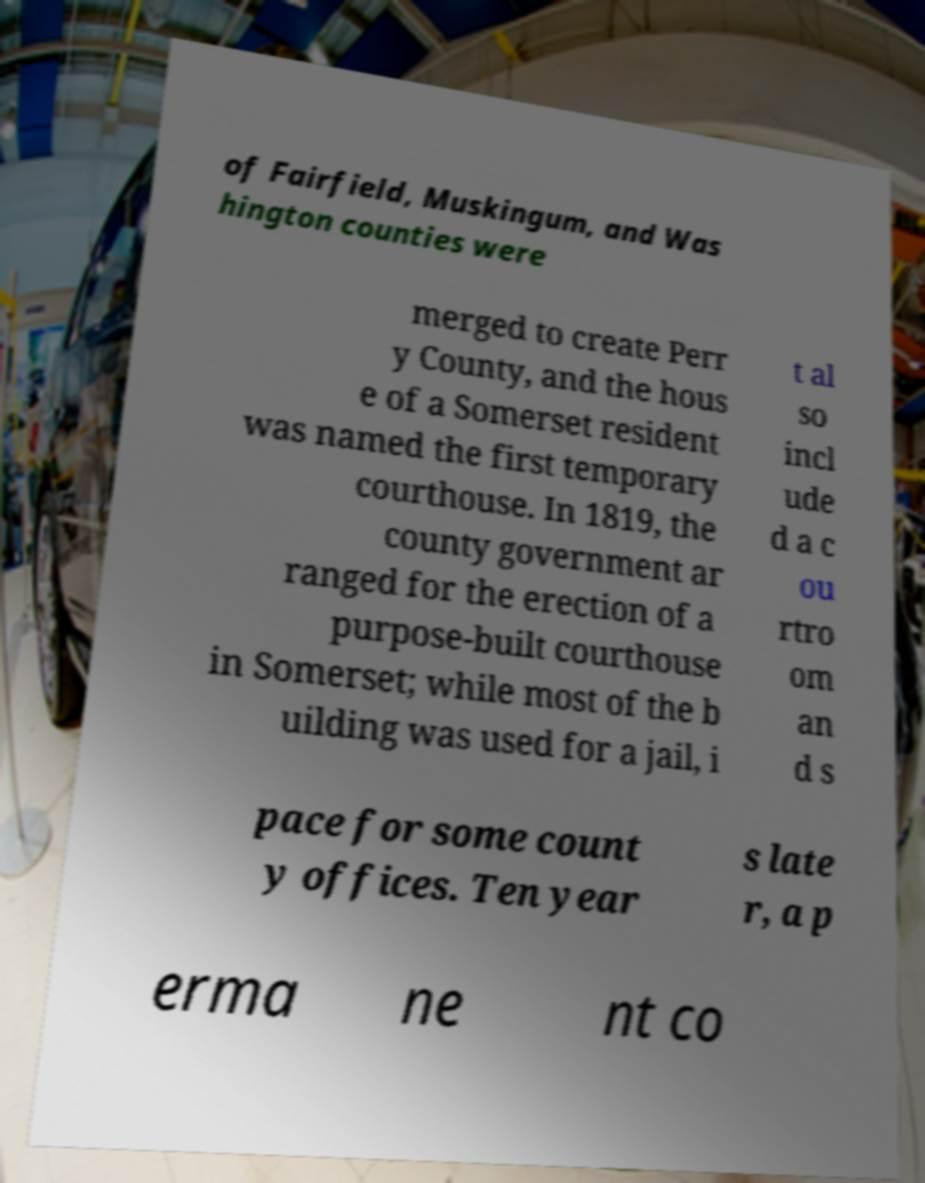Can you read and provide the text displayed in the image?This photo seems to have some interesting text. Can you extract and type it out for me? of Fairfield, Muskingum, and Was hington counties were merged to create Perr y County, and the hous e of a Somerset resident was named the first temporary courthouse. In 1819, the county government ar ranged for the erection of a purpose-built courthouse in Somerset; while most of the b uilding was used for a jail, i t al so incl ude d a c ou rtro om an d s pace for some count y offices. Ten year s late r, a p erma ne nt co 